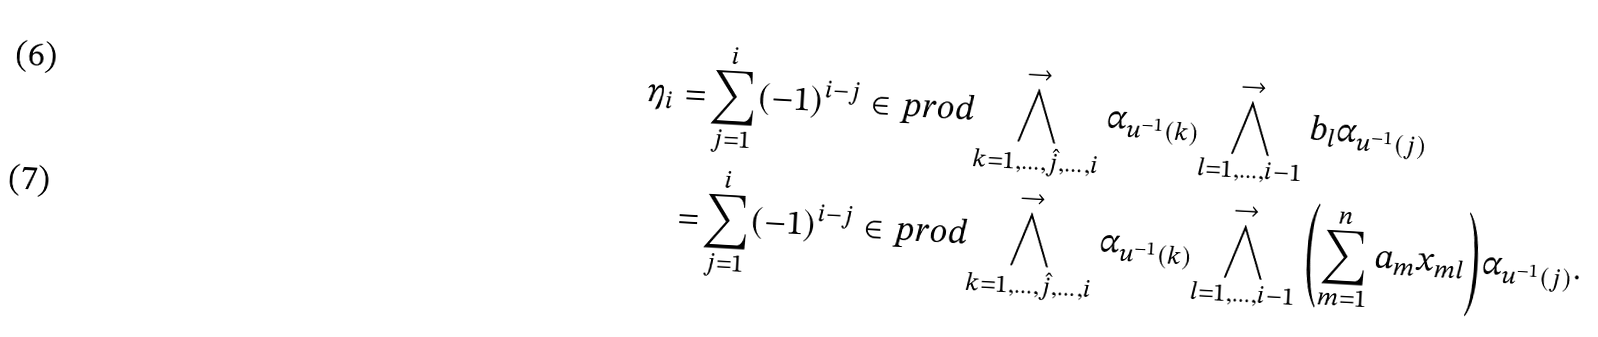<formula> <loc_0><loc_0><loc_500><loc_500>\eta _ { i } = & \sum _ { j = 1 } ^ { i } ( - 1 ) ^ { i - j } \in p r o d { \bigwedge ^ { \rightarrow } _ { k = 1 , \dots , \hat { j } , \dots , i } \alpha _ { u ^ { - 1 } ( k ) } } { \bigwedge ^ { \rightarrow } _ { l = 1 , \dots , i - 1 } b _ { l } } \alpha _ { u ^ { - 1 } ( j ) } \\ = & \sum _ { j = 1 } ^ { i } ( - 1 ) ^ { i - j } \in p r o d { \bigwedge ^ { \rightarrow } _ { k = 1 , \dots , \hat { j } , \dots , i } \alpha _ { u ^ { - 1 } ( k ) } } { \bigwedge ^ { \rightarrow } _ { l = 1 , \dots , i - 1 } \left ( \sum _ { m = 1 } ^ { n } a _ { m } x _ { m l } \right ) } \alpha _ { u ^ { - 1 } ( j ) } .</formula> 